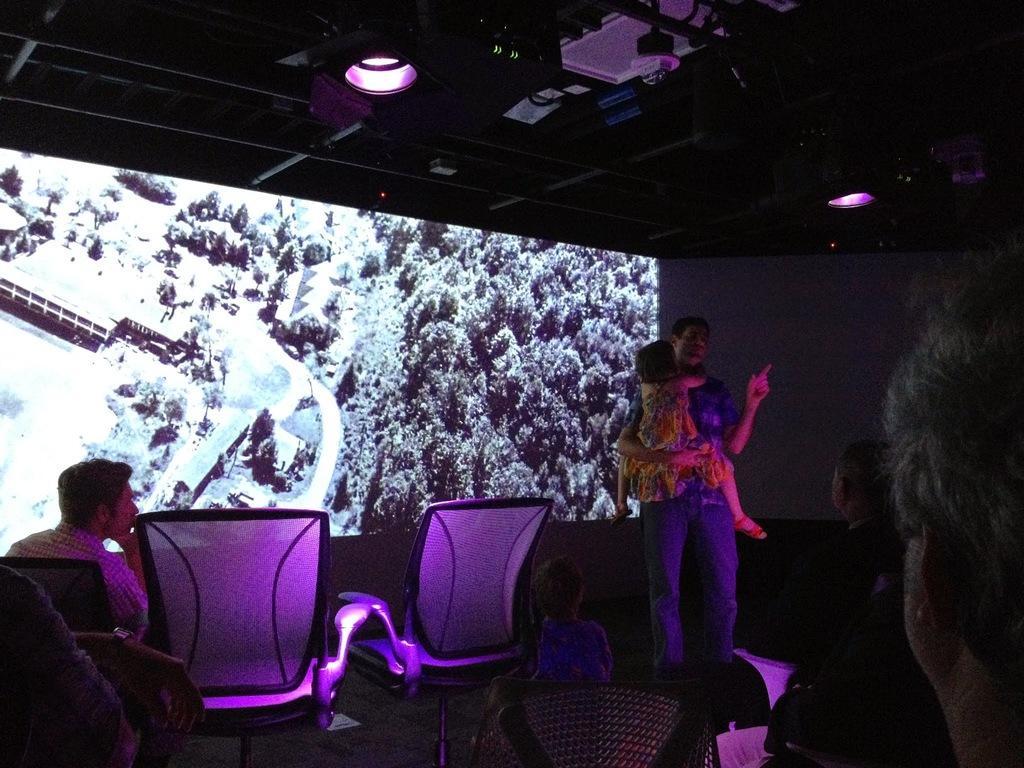Describe this image in one or two sentences. There are many people. Also there are chairs. Some are sitting on the chairs. And a person is holding a child. In the back there is a screen. On the ceiling there are lights. 